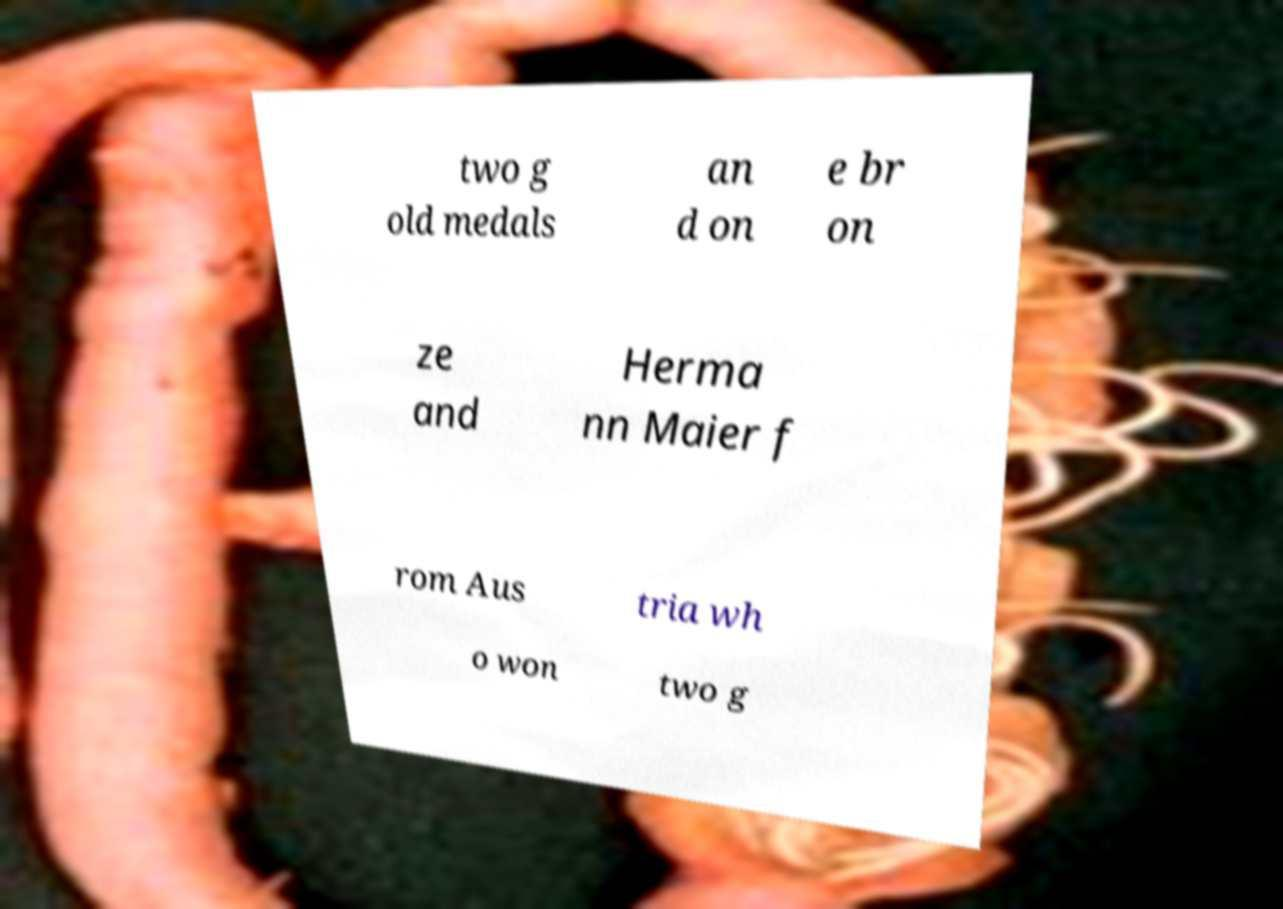Can you read and provide the text displayed in the image?This photo seems to have some interesting text. Can you extract and type it out for me? two g old medals an d on e br on ze and Herma nn Maier f rom Aus tria wh o won two g 